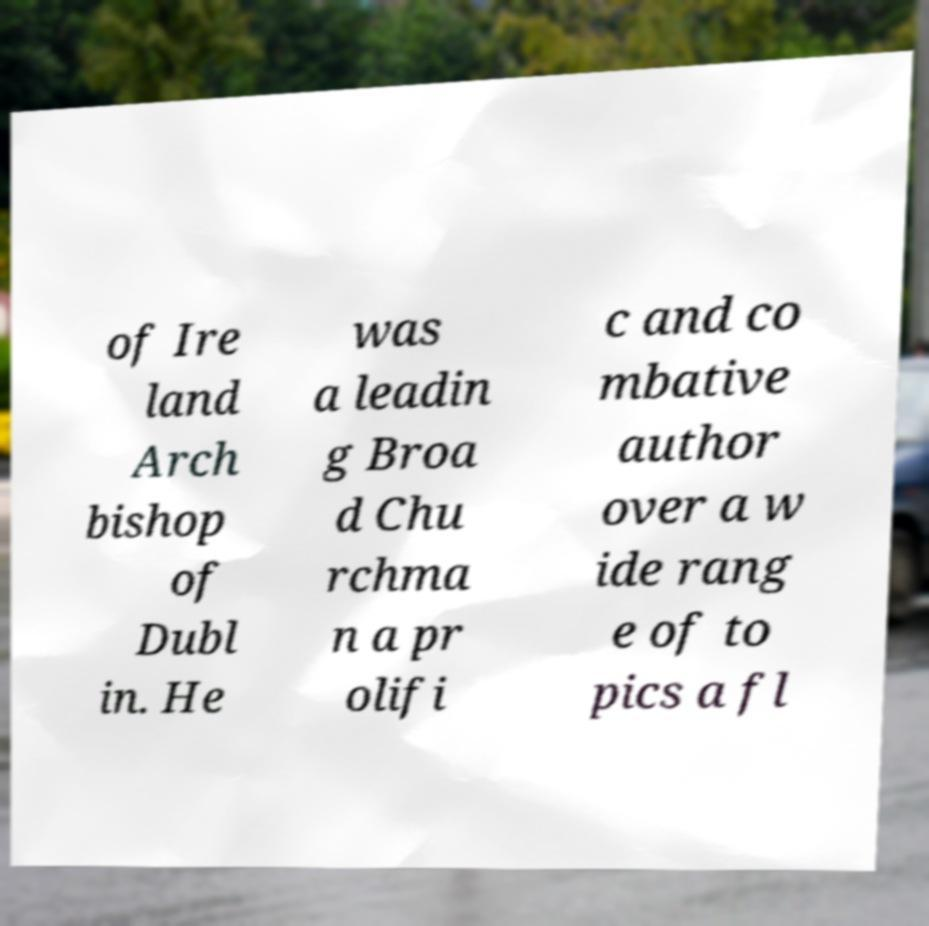Please read and relay the text visible in this image. What does it say? of Ire land Arch bishop of Dubl in. He was a leadin g Broa d Chu rchma n a pr olifi c and co mbative author over a w ide rang e of to pics a fl 